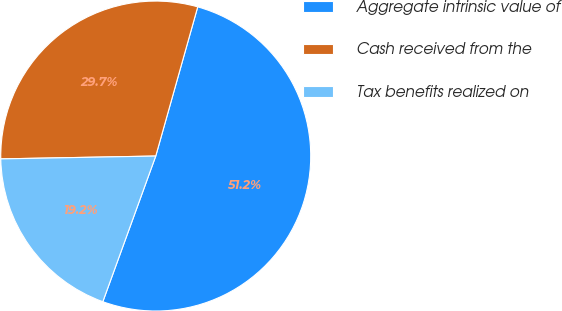Convert chart to OTSL. <chart><loc_0><loc_0><loc_500><loc_500><pie_chart><fcel>Aggregate intrinsic value of<fcel>Cash received from the<fcel>Tax benefits realized on<nl><fcel>51.18%<fcel>29.66%<fcel>19.16%<nl></chart> 